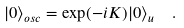Convert formula to latex. <formula><loc_0><loc_0><loc_500><loc_500>| 0 \rangle _ { o s c } = \exp ( - i K ) | 0 \rangle _ { u } \ \ .</formula> 